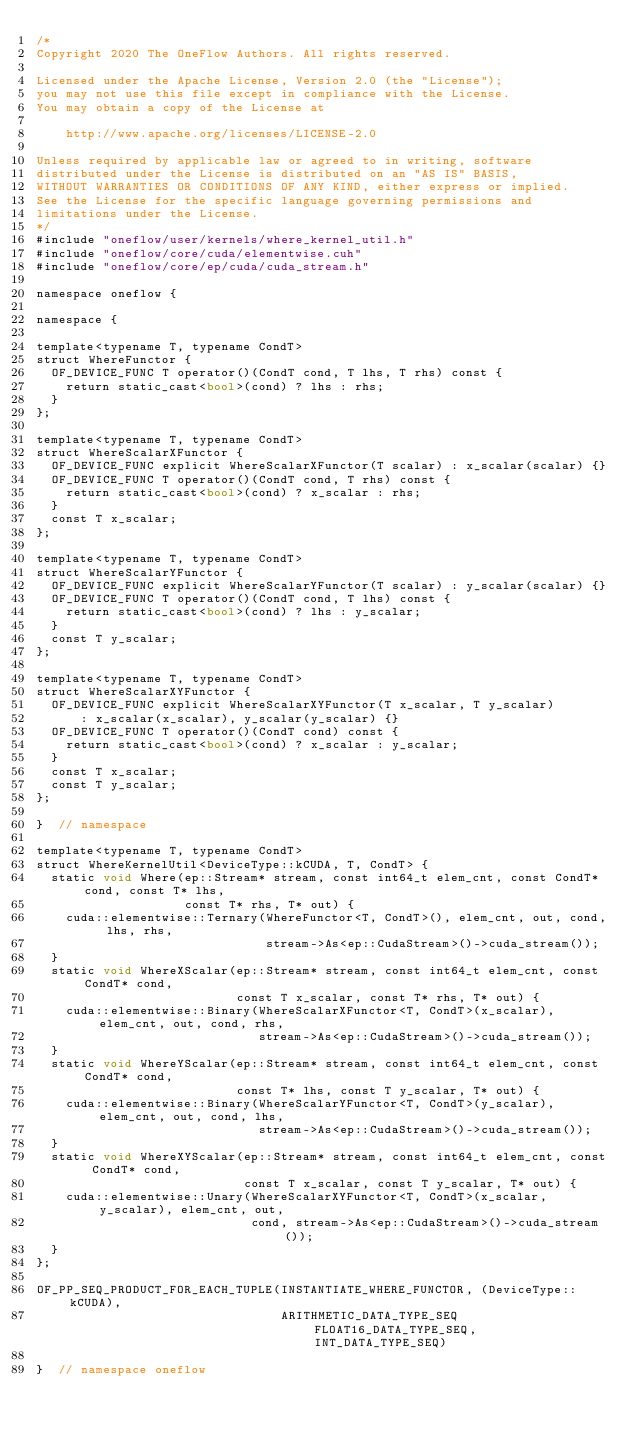<code> <loc_0><loc_0><loc_500><loc_500><_Cuda_>/*
Copyright 2020 The OneFlow Authors. All rights reserved.

Licensed under the Apache License, Version 2.0 (the "License");
you may not use this file except in compliance with the License.
You may obtain a copy of the License at

    http://www.apache.org/licenses/LICENSE-2.0

Unless required by applicable law or agreed to in writing, software
distributed under the License is distributed on an "AS IS" BASIS,
WITHOUT WARRANTIES OR CONDITIONS OF ANY KIND, either express or implied.
See the License for the specific language governing permissions and
limitations under the License.
*/
#include "oneflow/user/kernels/where_kernel_util.h"
#include "oneflow/core/cuda/elementwise.cuh"
#include "oneflow/core/ep/cuda/cuda_stream.h"

namespace oneflow {

namespace {

template<typename T, typename CondT>
struct WhereFunctor {
  OF_DEVICE_FUNC T operator()(CondT cond, T lhs, T rhs) const {
    return static_cast<bool>(cond) ? lhs : rhs;
  }
};

template<typename T, typename CondT>
struct WhereScalarXFunctor {
  OF_DEVICE_FUNC explicit WhereScalarXFunctor(T scalar) : x_scalar(scalar) {}
  OF_DEVICE_FUNC T operator()(CondT cond, T rhs) const {
    return static_cast<bool>(cond) ? x_scalar : rhs;
  }
  const T x_scalar;
};

template<typename T, typename CondT>
struct WhereScalarYFunctor {
  OF_DEVICE_FUNC explicit WhereScalarYFunctor(T scalar) : y_scalar(scalar) {}
  OF_DEVICE_FUNC T operator()(CondT cond, T lhs) const {
    return static_cast<bool>(cond) ? lhs : y_scalar;
  }
  const T y_scalar;
};

template<typename T, typename CondT>
struct WhereScalarXYFunctor {
  OF_DEVICE_FUNC explicit WhereScalarXYFunctor(T x_scalar, T y_scalar)
      : x_scalar(x_scalar), y_scalar(y_scalar) {}
  OF_DEVICE_FUNC T operator()(CondT cond) const {
    return static_cast<bool>(cond) ? x_scalar : y_scalar;
  }
  const T x_scalar;
  const T y_scalar;
};

}  // namespace

template<typename T, typename CondT>
struct WhereKernelUtil<DeviceType::kCUDA, T, CondT> {
  static void Where(ep::Stream* stream, const int64_t elem_cnt, const CondT* cond, const T* lhs,
                    const T* rhs, T* out) {
    cuda::elementwise::Ternary(WhereFunctor<T, CondT>(), elem_cnt, out, cond, lhs, rhs,
                               stream->As<ep::CudaStream>()->cuda_stream());
  }
  static void WhereXScalar(ep::Stream* stream, const int64_t elem_cnt, const CondT* cond,
                           const T x_scalar, const T* rhs, T* out) {
    cuda::elementwise::Binary(WhereScalarXFunctor<T, CondT>(x_scalar), elem_cnt, out, cond, rhs,
                              stream->As<ep::CudaStream>()->cuda_stream());
  }
  static void WhereYScalar(ep::Stream* stream, const int64_t elem_cnt, const CondT* cond,
                           const T* lhs, const T y_scalar, T* out) {
    cuda::elementwise::Binary(WhereScalarYFunctor<T, CondT>(y_scalar), elem_cnt, out, cond, lhs,
                              stream->As<ep::CudaStream>()->cuda_stream());
  }
  static void WhereXYScalar(ep::Stream* stream, const int64_t elem_cnt, const CondT* cond,
                            const T x_scalar, const T y_scalar, T* out) {
    cuda::elementwise::Unary(WhereScalarXYFunctor<T, CondT>(x_scalar, y_scalar), elem_cnt, out,
                             cond, stream->As<ep::CudaStream>()->cuda_stream());
  }
};

OF_PP_SEQ_PRODUCT_FOR_EACH_TUPLE(INSTANTIATE_WHERE_FUNCTOR, (DeviceType::kCUDA),
                                 ARITHMETIC_DATA_TYPE_SEQ FLOAT16_DATA_TYPE_SEQ, INT_DATA_TYPE_SEQ)

}  // namespace oneflow
</code> 